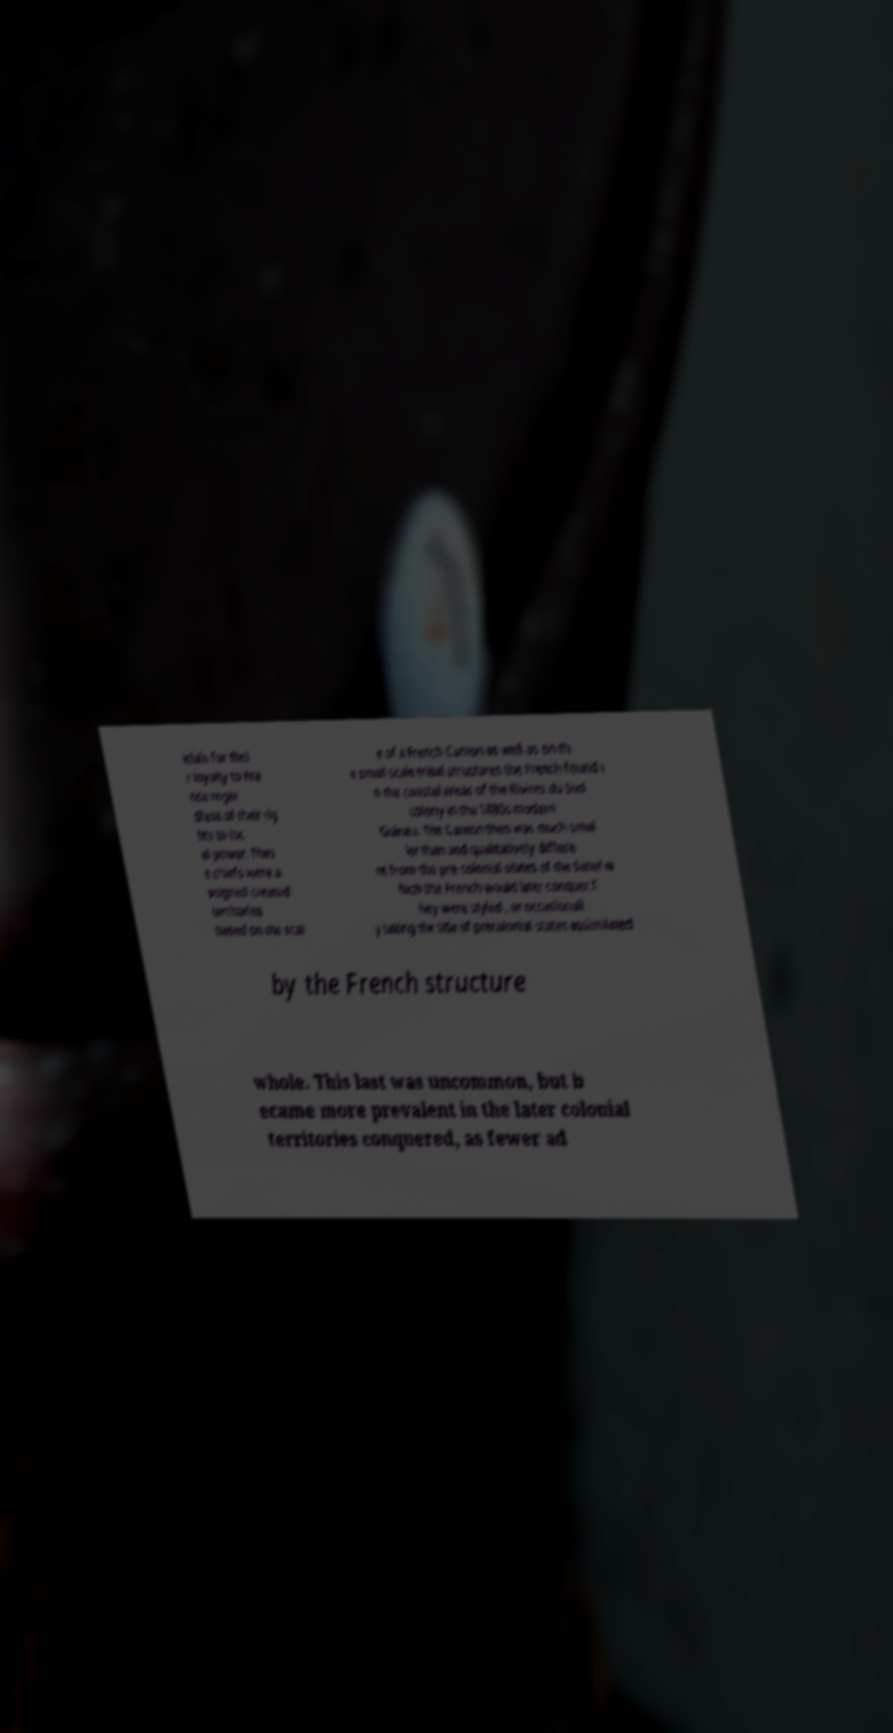There's text embedded in this image that I need extracted. Can you transcribe it verbatim? icials for thei r loyalty to Fra nce regar dless of their rig hts to loc al power. Thes e chiefs were a ssigned created territories based on the scal e of a French Canton as well as on th e small scale tribal structures the French found i n the coastal areas of the Rivires du Sud colony in the 1880s modern Guinea. The Canton then was much smal ler than and qualitatively differe nt from the pre-colonial states of the Sahel w hich the French would later conquer.T hey were styled , or occasionall y taking the title of precolonial states assimilated by the French structure whole. This last was uncommon, but b ecame more prevalent in the later colonial territories conquered, as fewer ad 